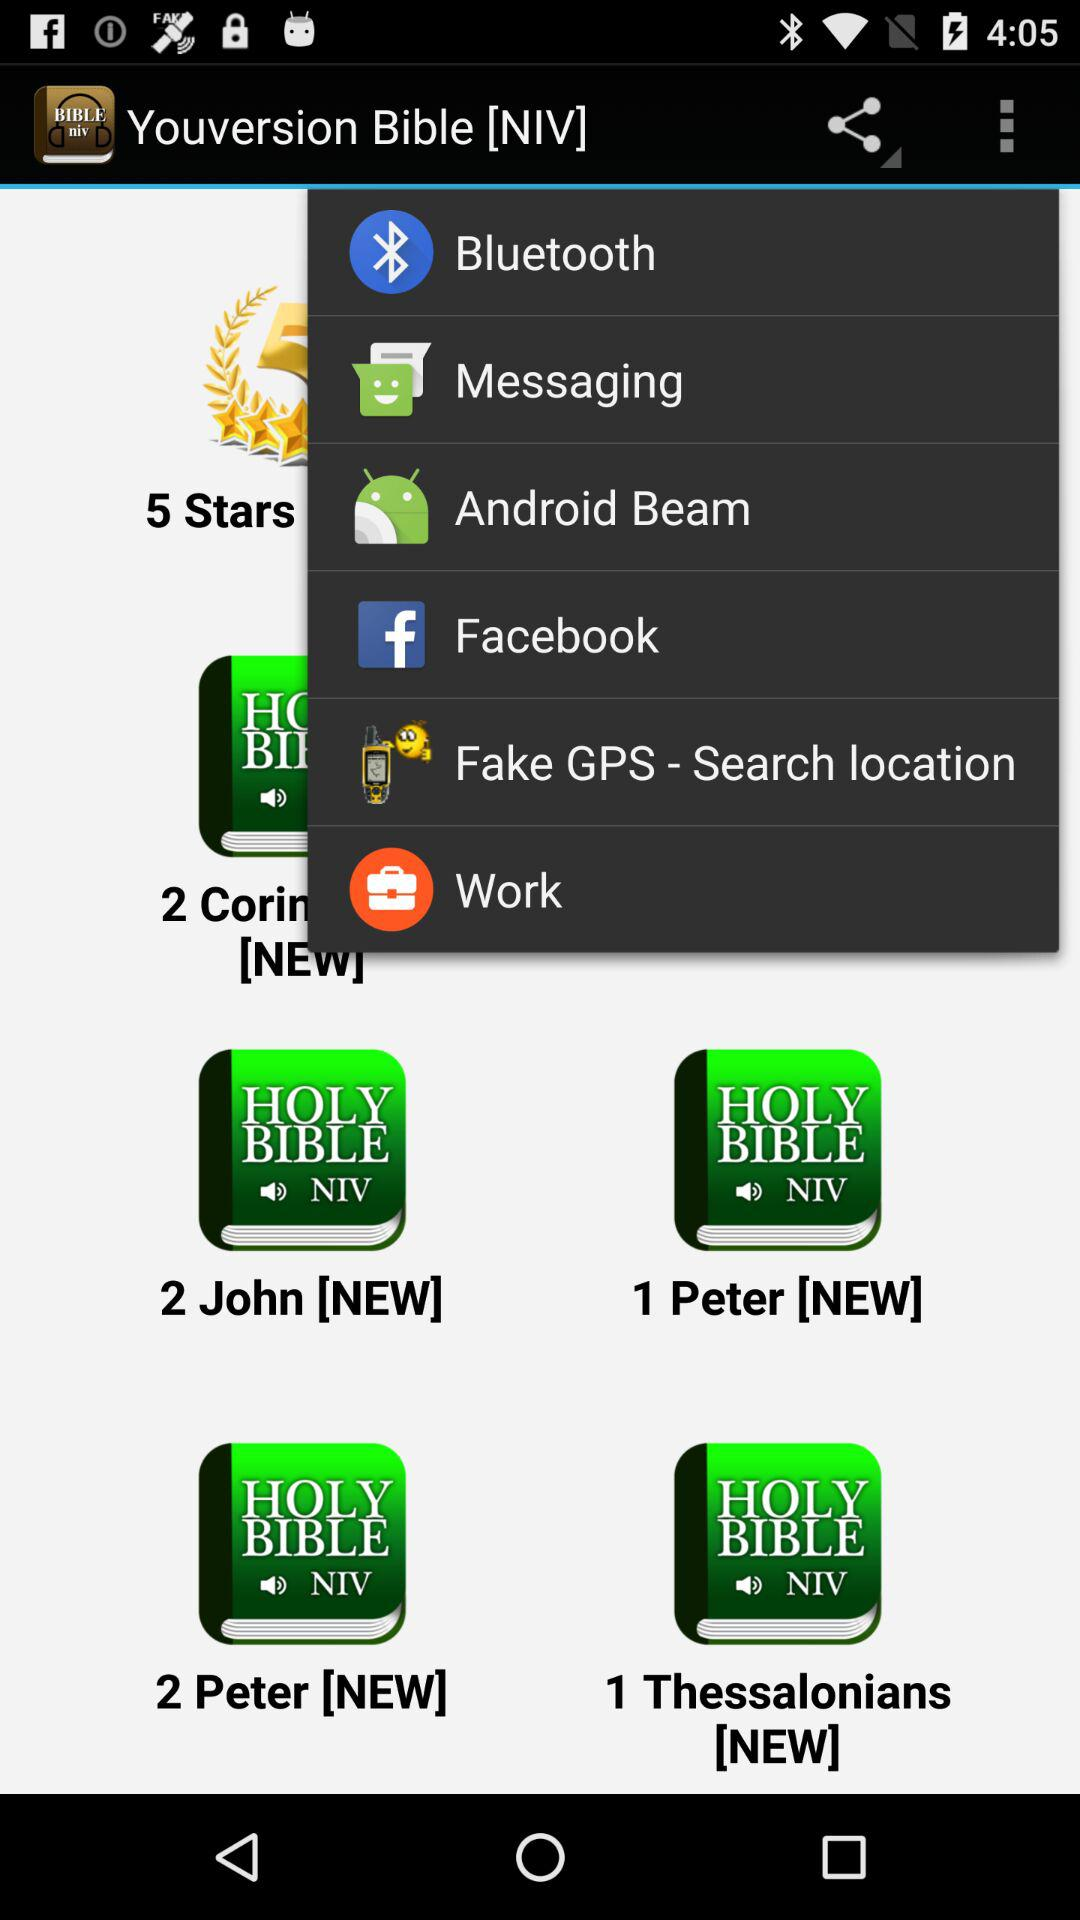What is the name of the application? The name of the application is "Youversion Bible [NIV]". 